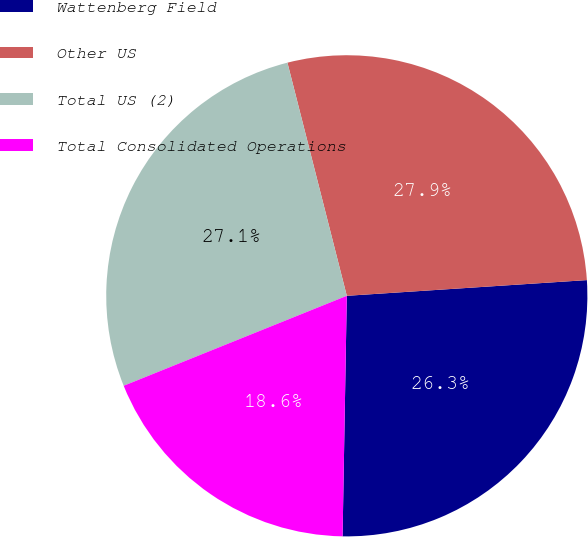<chart> <loc_0><loc_0><loc_500><loc_500><pie_chart><fcel>Wattenberg Field<fcel>Other US<fcel>Total US (2)<fcel>Total Consolidated Operations<nl><fcel>26.32%<fcel>27.93%<fcel>27.13%<fcel>18.62%<nl></chart> 